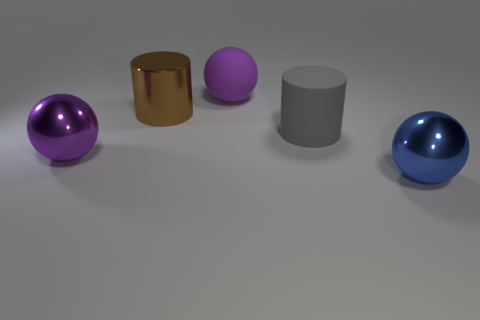How many other things are the same shape as the blue shiny object?
Give a very brief answer. 2. What shape is the other big object that is the same material as the gray thing?
Make the answer very short. Sphere. Are there any big brown objects?
Your answer should be compact. Yes. Is the number of big purple metallic spheres that are on the right side of the brown metal cylinder less than the number of big cylinders behind the big matte cylinder?
Ensure brevity in your answer.  Yes. The big purple thing that is on the right side of the metal cylinder has what shape?
Your answer should be very brief. Sphere. Does the big brown cylinder have the same material as the gray thing?
Ensure brevity in your answer.  No. Is there anything else that is made of the same material as the blue thing?
Provide a succinct answer. Yes. There is a large gray thing that is the same shape as the large brown shiny thing; what material is it?
Your answer should be very brief. Rubber. Are there fewer purple rubber balls that are left of the metallic cylinder than big red blocks?
Your answer should be very brief. No. There is a big brown cylinder; what number of brown metallic objects are behind it?
Provide a succinct answer. 0. 